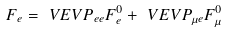Convert formula to latex. <formula><loc_0><loc_0><loc_500><loc_500>F _ { e } & = \ V E V { P _ { e e } } F _ { e } ^ { 0 } + \ V E V { P _ { \mu e } } F _ { \mu } ^ { 0 }</formula> 